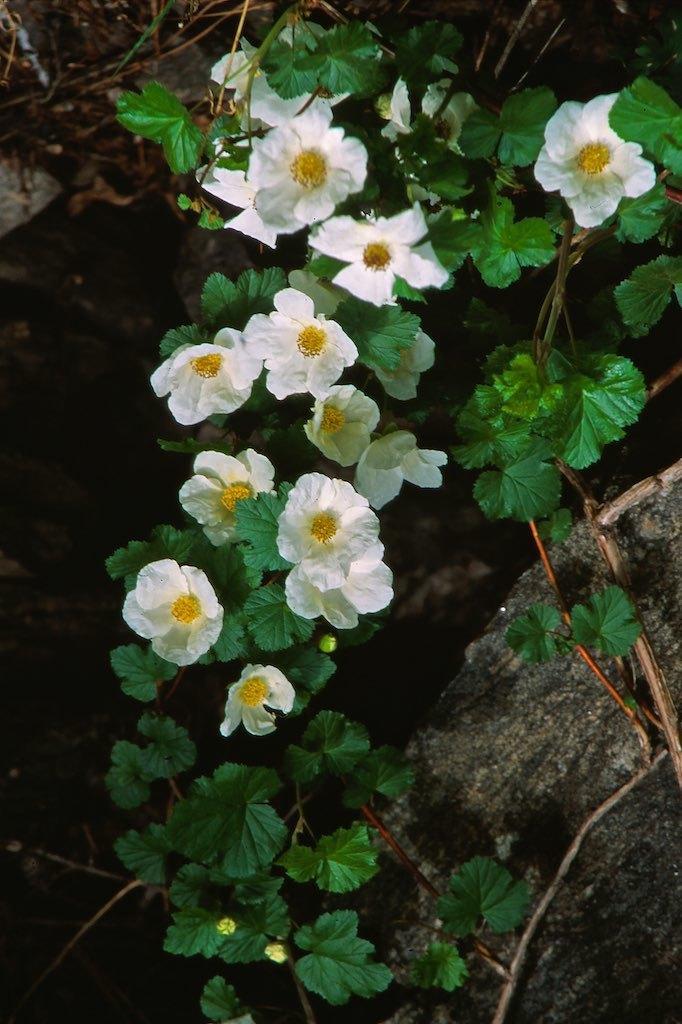Can you describe this image briefly? In this image we can see white color flowers to a plant. 